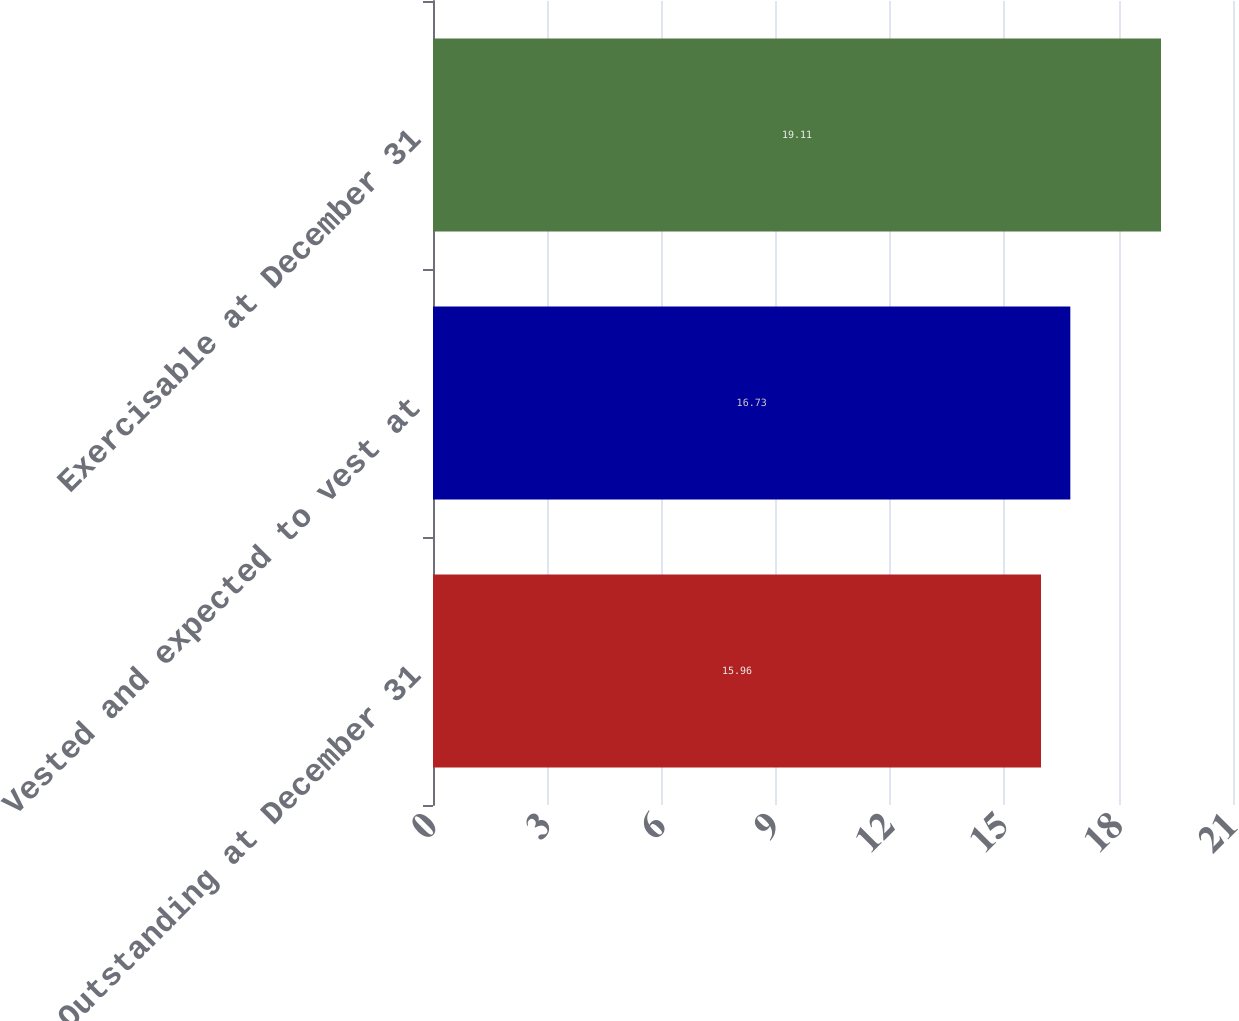Convert chart to OTSL. <chart><loc_0><loc_0><loc_500><loc_500><bar_chart><fcel>Outstanding at December 31<fcel>Vested and expected to vest at<fcel>Exercisable at December 31<nl><fcel>15.96<fcel>16.73<fcel>19.11<nl></chart> 